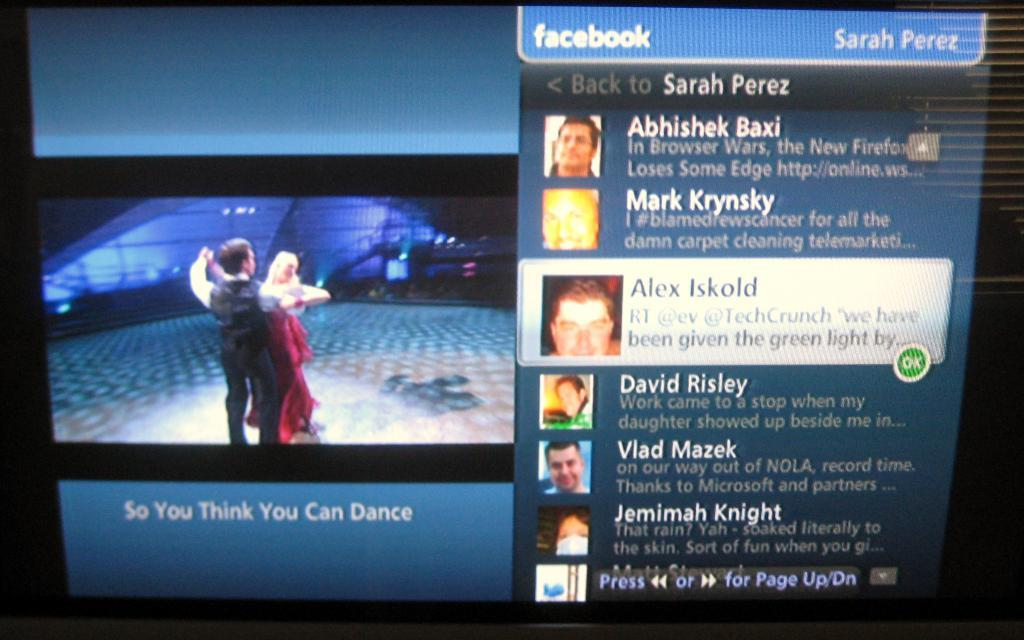<image>
Describe the image concisely. some names on a screen with Alex Iskold on it 